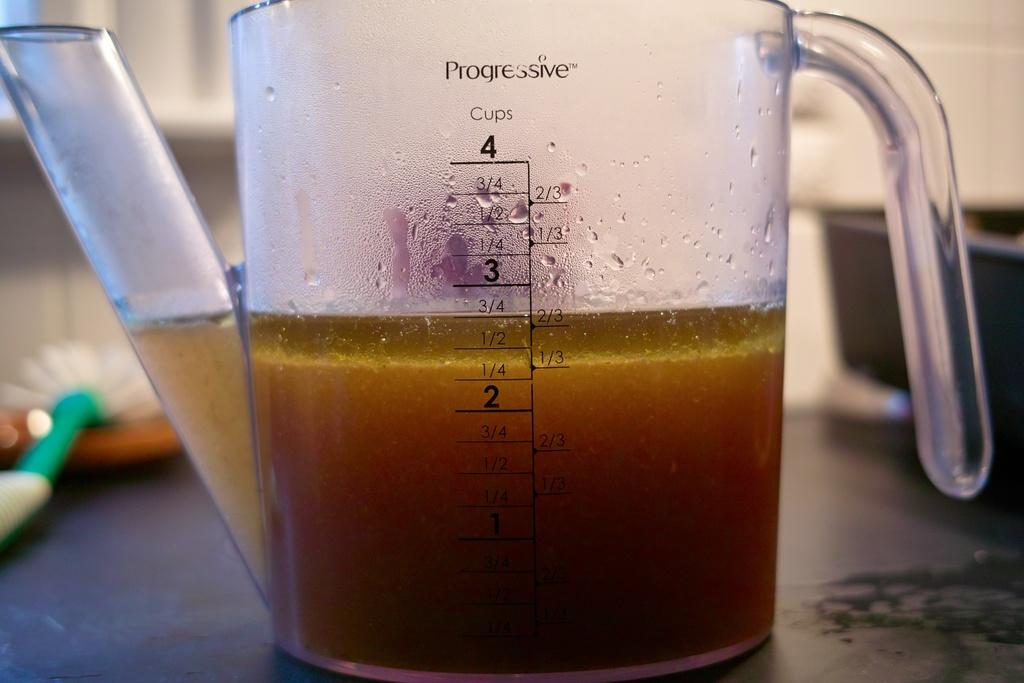<image>
Create a compact narrative representing the image presented. A measuring cup with a spout has a 4 cup capacity. 